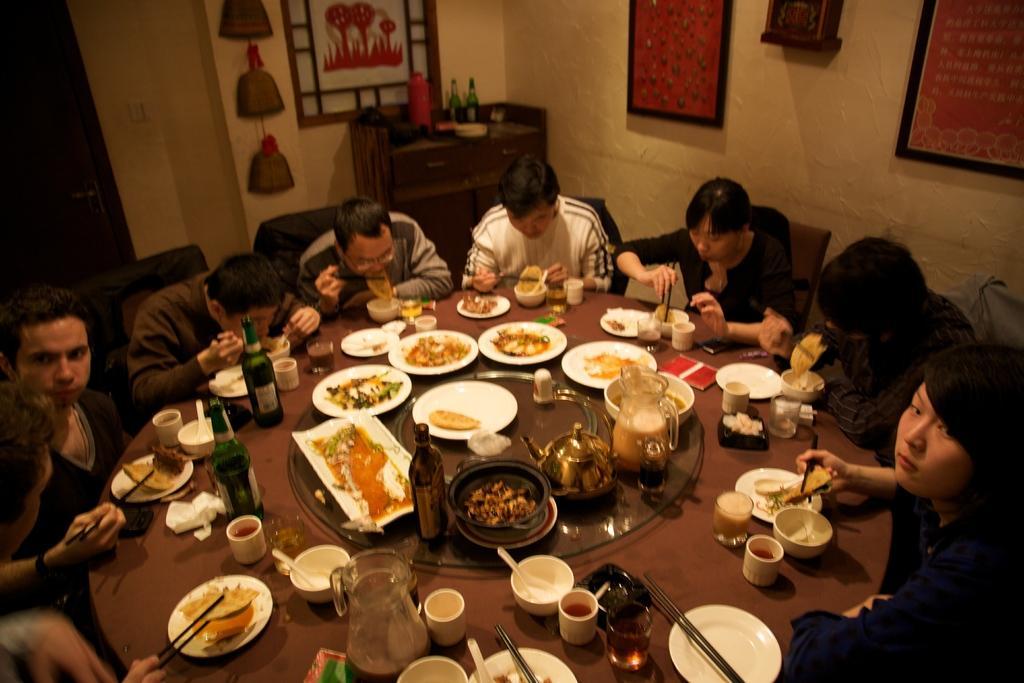Please provide a concise description of this image. In this picture I can see there are a few people sitting on the chairs, there is some food placed on the plates, bowls and there are chop sticks and wine bottles. In the backdrop there is a wall with photo frames. 